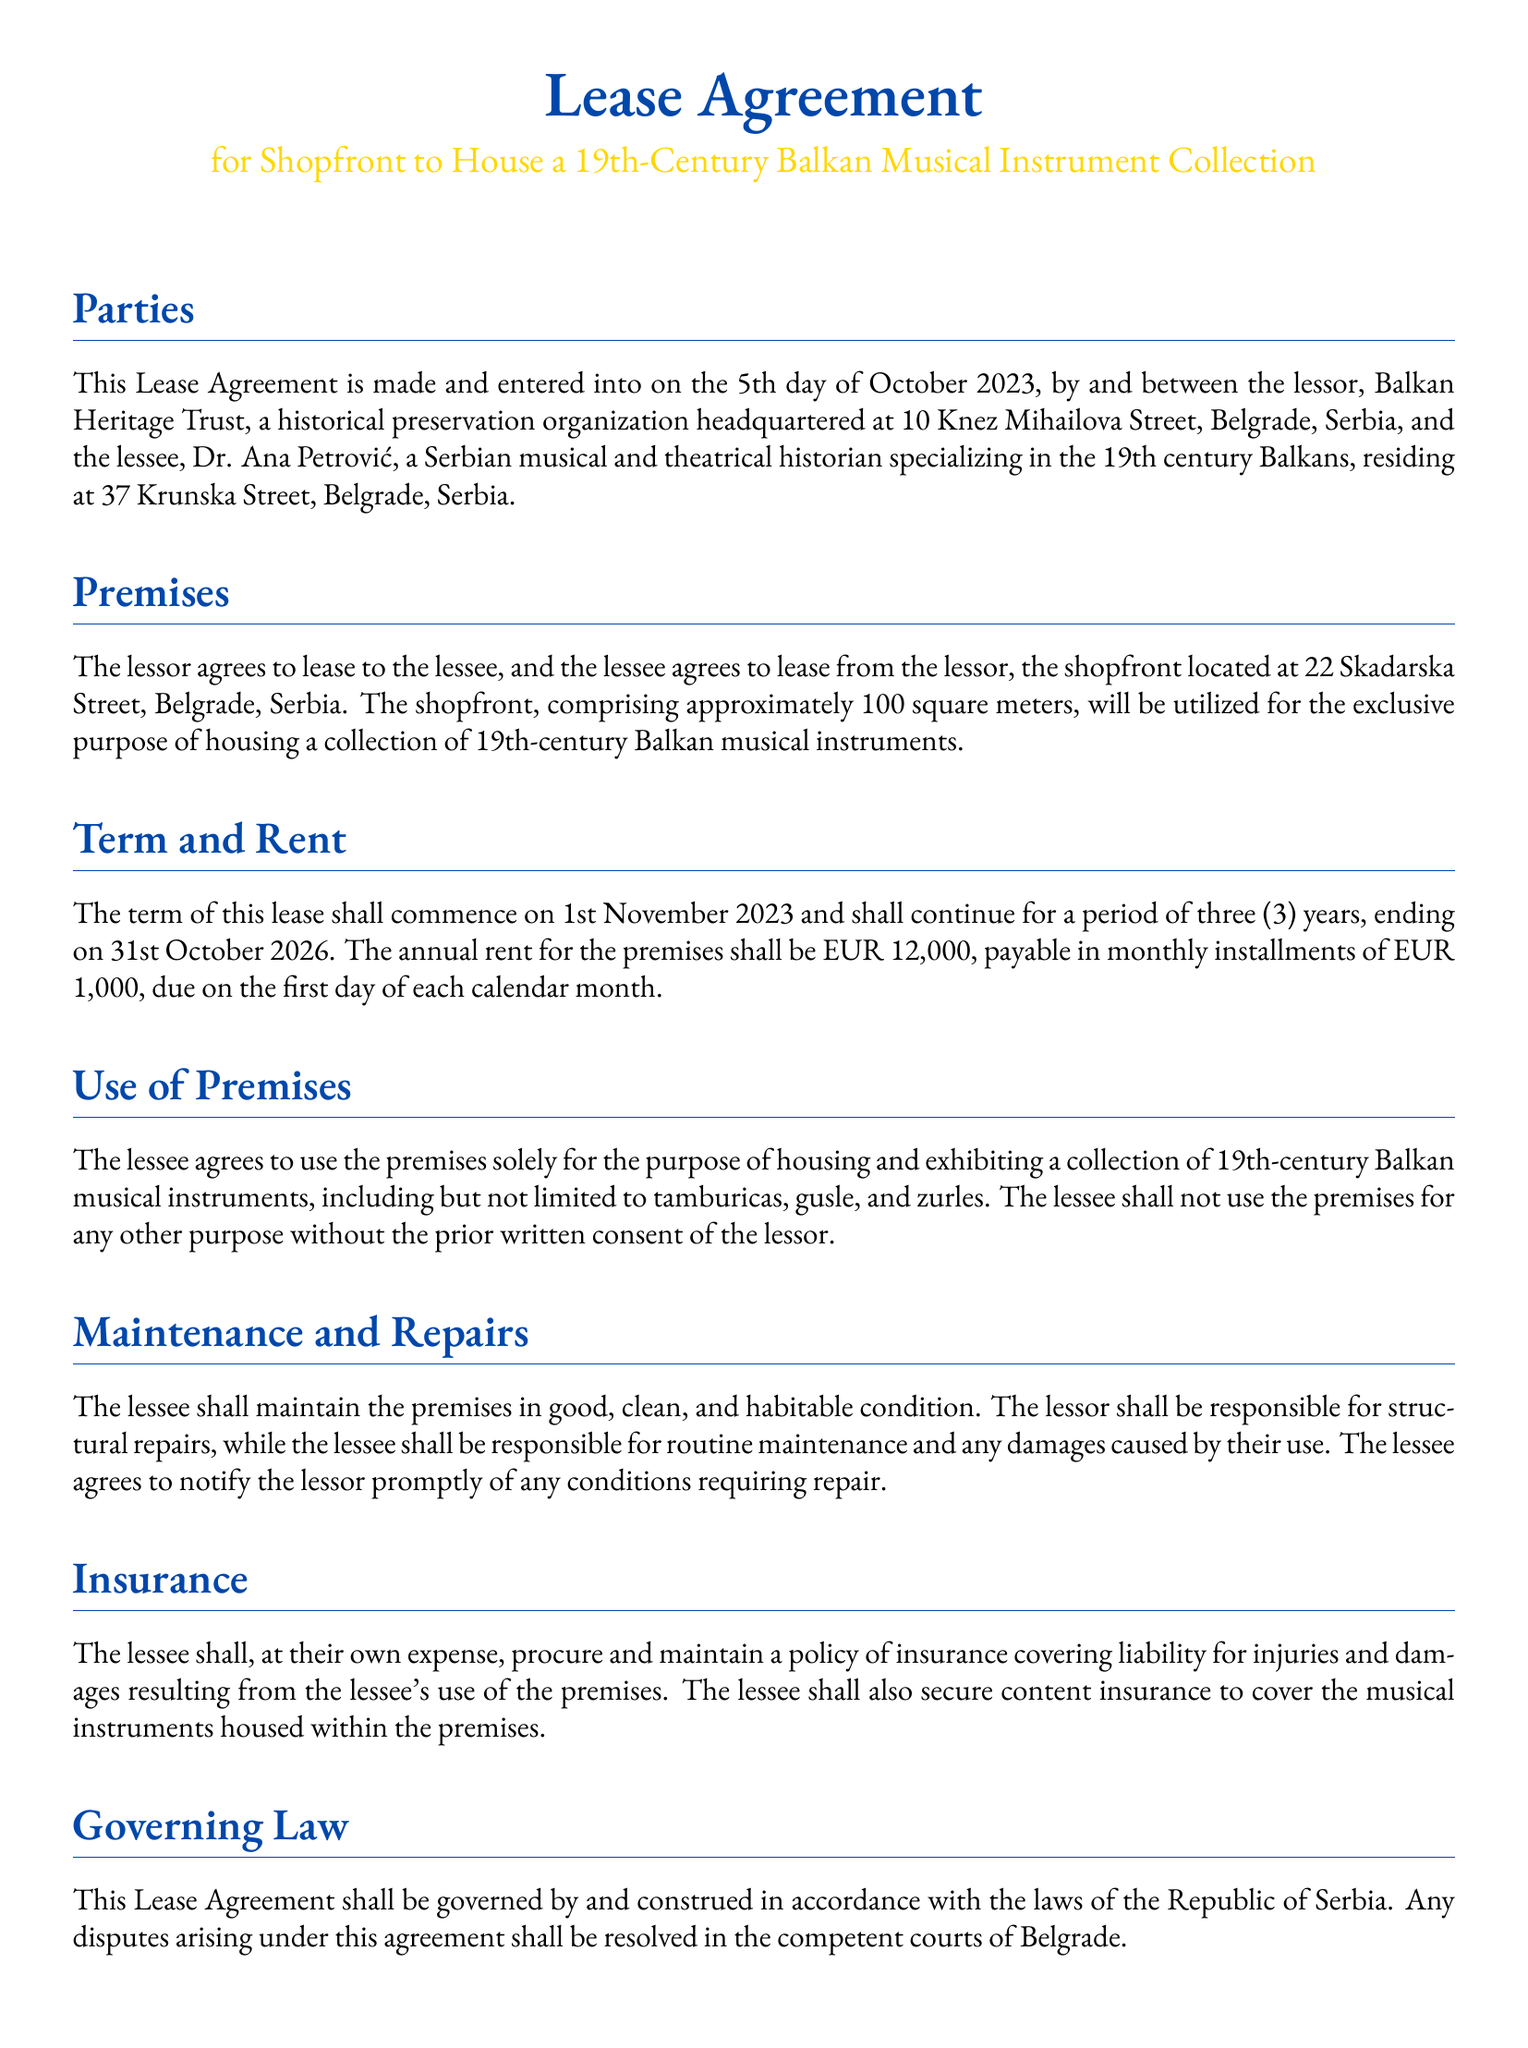What is the commencement date of the lease? The agreement states that the lease shall commence on 1st November 2023.
Answer: 1st November 2023 What is the annual rent for the premises? The document specifies that the annual rent for the premises is EUR 12,000.
Answer: EUR 12,000 Who is the lessee? The lessee is Dr. Ana Petrović, a Serbian musical and theatrical historian.
Answer: Dr. Ana Petrović What is the address of the lessor? The lessor's address is provided as 10 Knez Mihailova Street, Belgrade, Serbia.
Answer: 10 Knez Mihailova Street, Belgrade, Serbia How long is the term of the lease? The lease term is stated to continue for a period of three years, ending on 31st October 2026.
Answer: three years What is the monthly rent amount? The lease specifies that the monthly rent amount is EUR 1,000.
Answer: EUR 1,000 What type of insurance is the lessee required to procure? The lessee is required to procure liability and content insurance.
Answer: liability and content insurance What is the purpose of using the premises? The premises shall be used solely for housing and exhibiting a collection of 19th-century Balkan musical instruments.
Answer: housing and exhibiting a collection of 19th-century Balkan musical instruments Who is responsible for structural repairs? The document states that the lessor shall be responsible for structural repairs.
Answer: lessor 